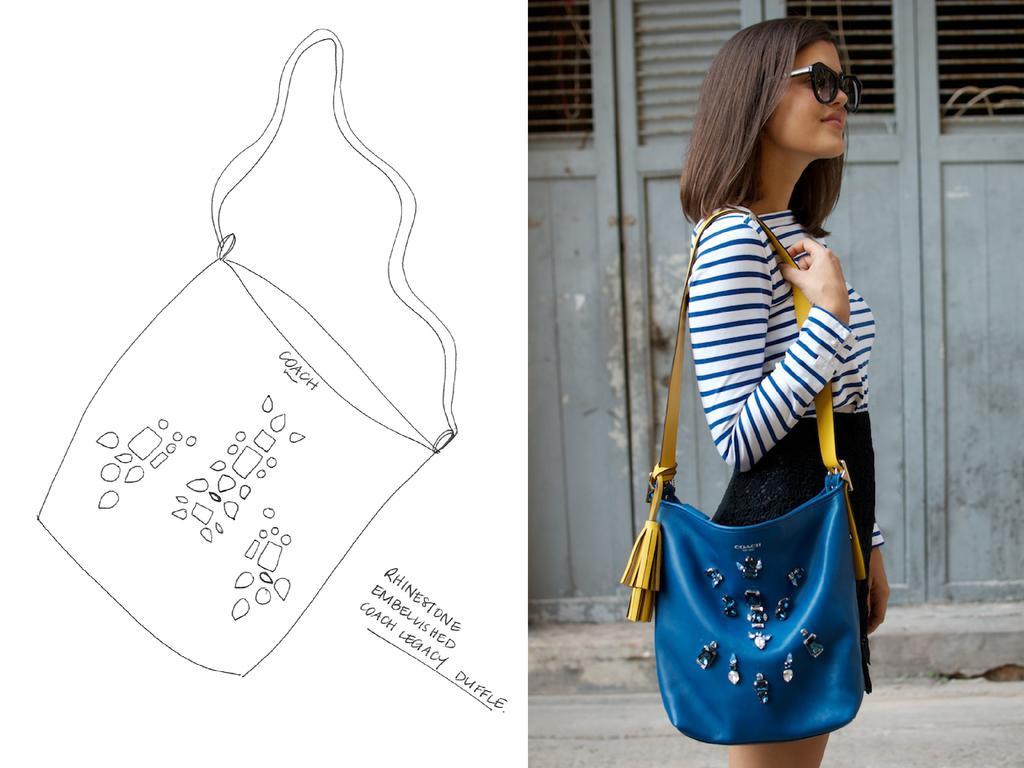Could you give a brief overview of what you see in this image? On the right we can see one woman standing and holding handbag. And coming to back we can see door. The left we can see paper written as "Coach". 